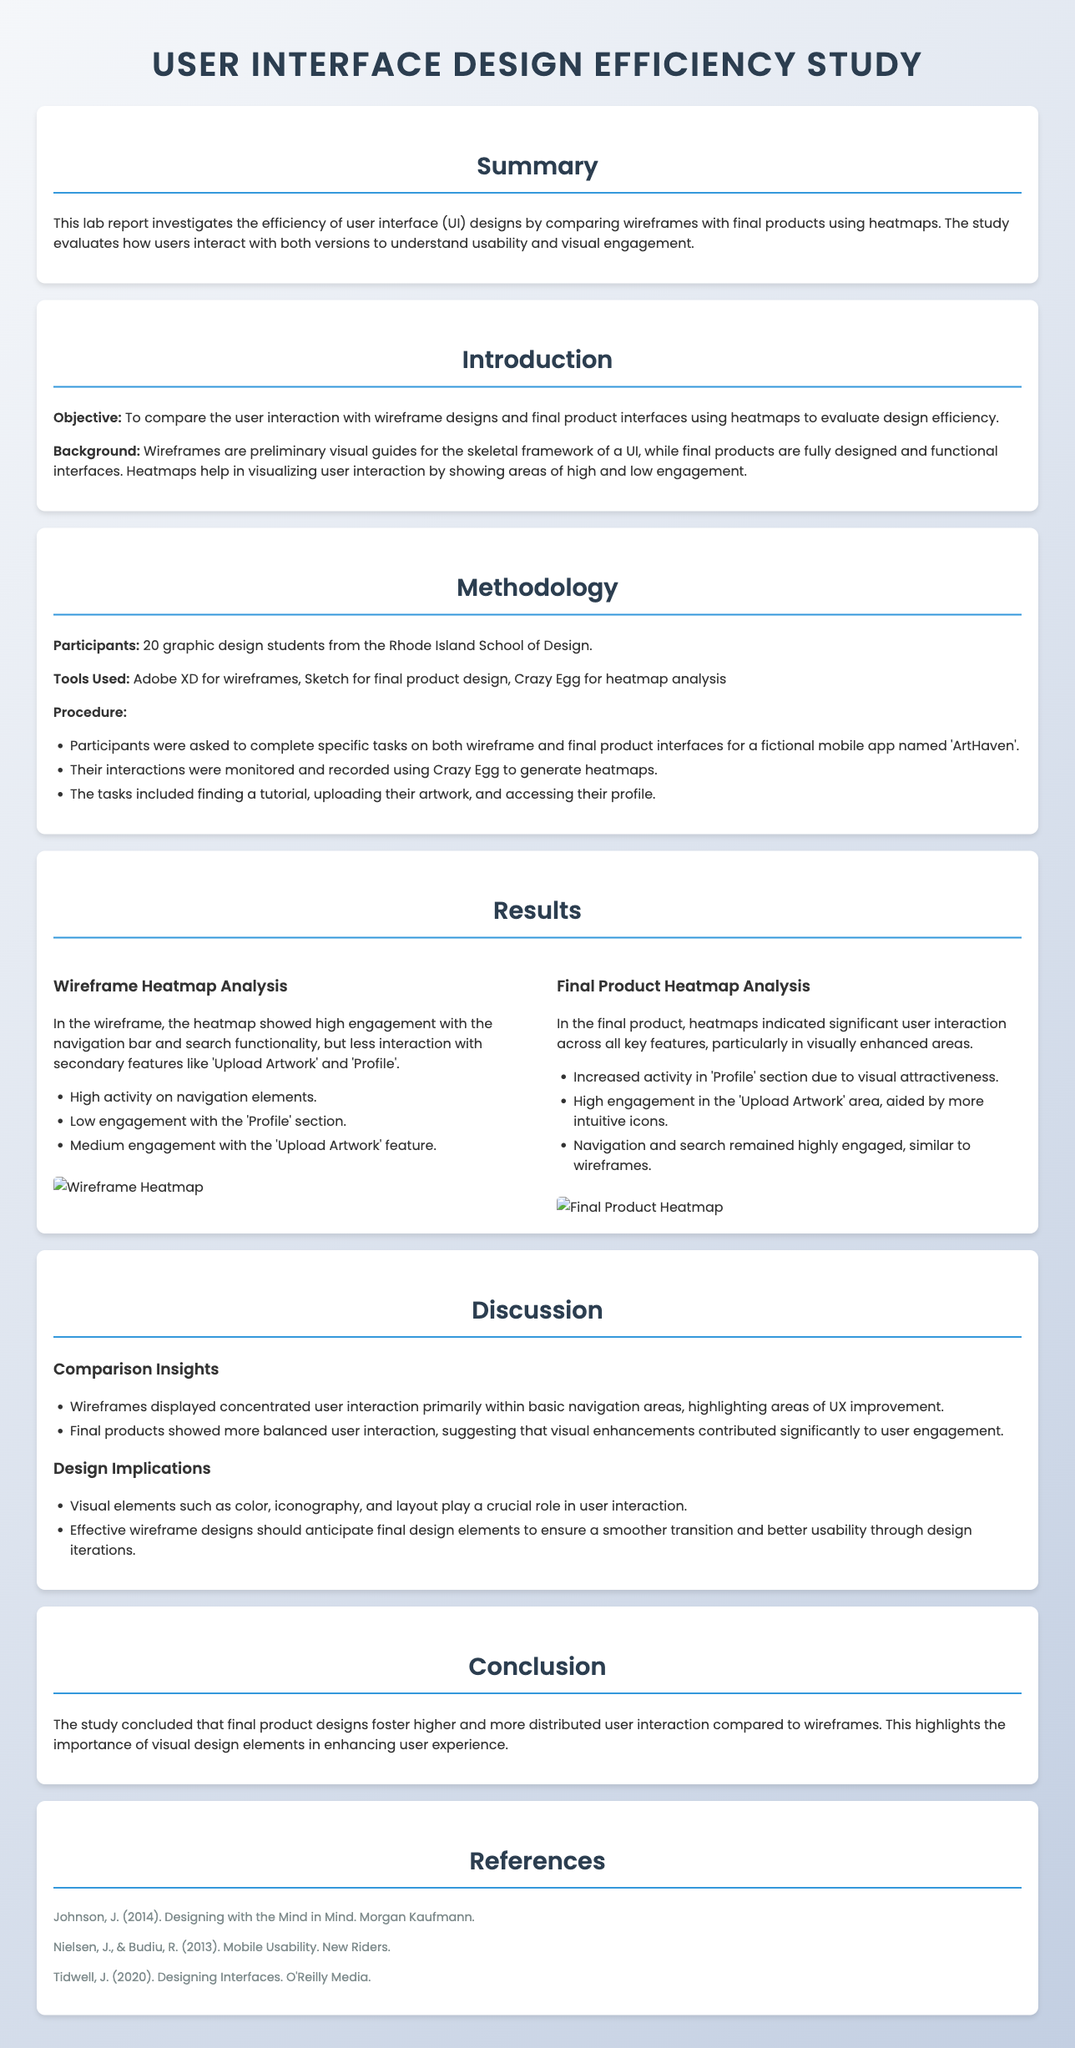what is the objective of this study? The objective is to compare user interaction with wireframe designs and final product interfaces using heatmaps to evaluate design efficiency.
Answer: to compare user interaction with wireframe designs and final product interfaces using heatmaps to evaluate design efficiency how many participants were involved in the study? The participants were 20 graphic design students from the Rhode Island School of Design.
Answer: 20 which tools were used for the analysis in this study? The report mentions the use of Adobe XD for wireframes, Sketch for final product design, and Crazy Egg for heatmap analysis.
Answer: Adobe XD, Sketch, Crazy Egg what area showed increased user activity in the final product compared to the wireframe? The final product heatmap analysis indicated increased activity in the 'Profile' section due to visual attractiveness.
Answer: 'Profile' section what is one implication of the research findings? One implication is that visual elements such as color, iconography, and layout play a crucial role in user interaction.
Answer: visual elements play a crucial role in user interaction what was the fictional mobile app used in this study? The fictional mobile app used in this study is named 'ArtHaven'.
Answer: ArtHaven what contributes significantly to user engagement according to the discussion section? The discussion emphasizes that visual enhancements contributed significantly to user engagement.
Answer: visual enhancements what did the wireframe heatmap show about user interaction? The wireframe heatmap showed high engagement with the navigation bar and search functionality.
Answer: high engagement with the navigation bar and search functionality 